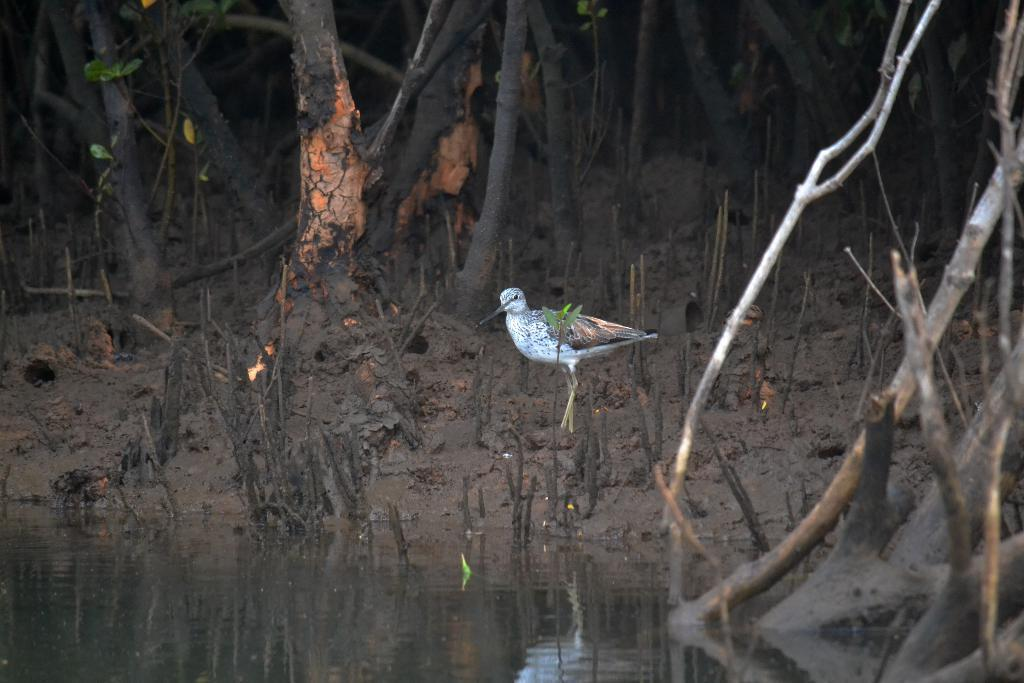What type of animal can be seen in the image? There is a bird in the image. Where is the bird located? The bird is on the land. What can be found on the land in the image? The land has plants. What structure is visible in the image? There is a tree trunk in the image. What is visible at the bottom of the image? There is water visible at the bottom of the image. What can be seen on the right side of the image? There are branches on the right side of the image. How many legs does the bird have in the image? The bird has two legs in the image. What type of nose can be seen on the bird in the image? Birds do not have noses like humans; they have a beak for their respiratory and feeding functions. Can you tell me how many cellars are visible in the image? There are no cellars present in the image. 